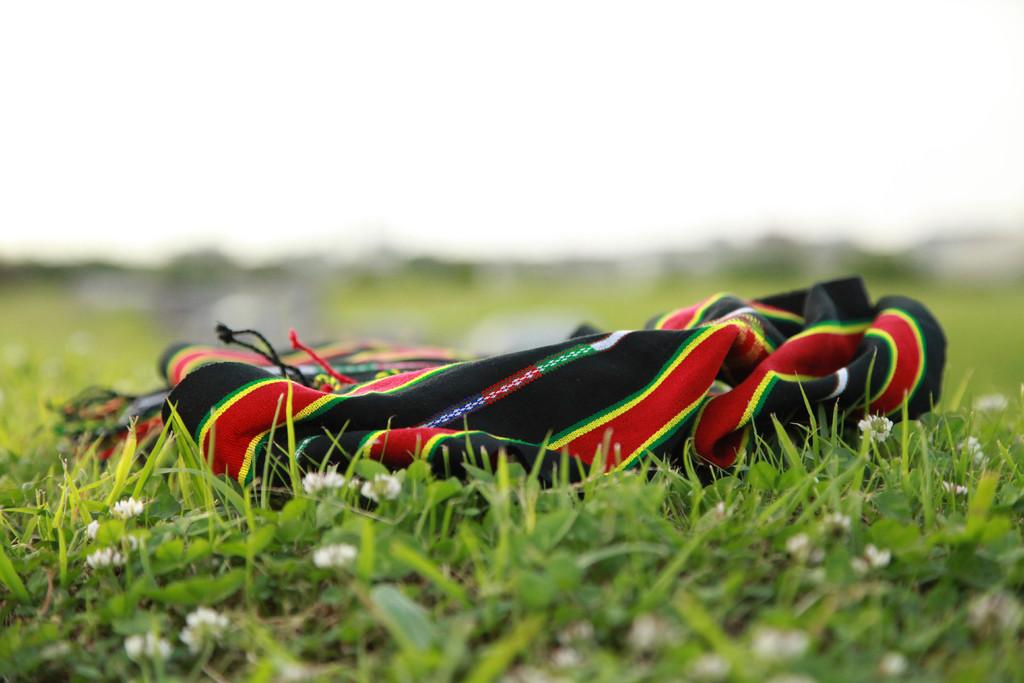What is placed on the grass in the image? There is a cloth on the grass. Can you describe the background of the image? The background of the image is blurred. What type of silver faucet can be seen in the image? There is no silver faucet present in the image; it only features a cloth on the grass with a blurred background. 